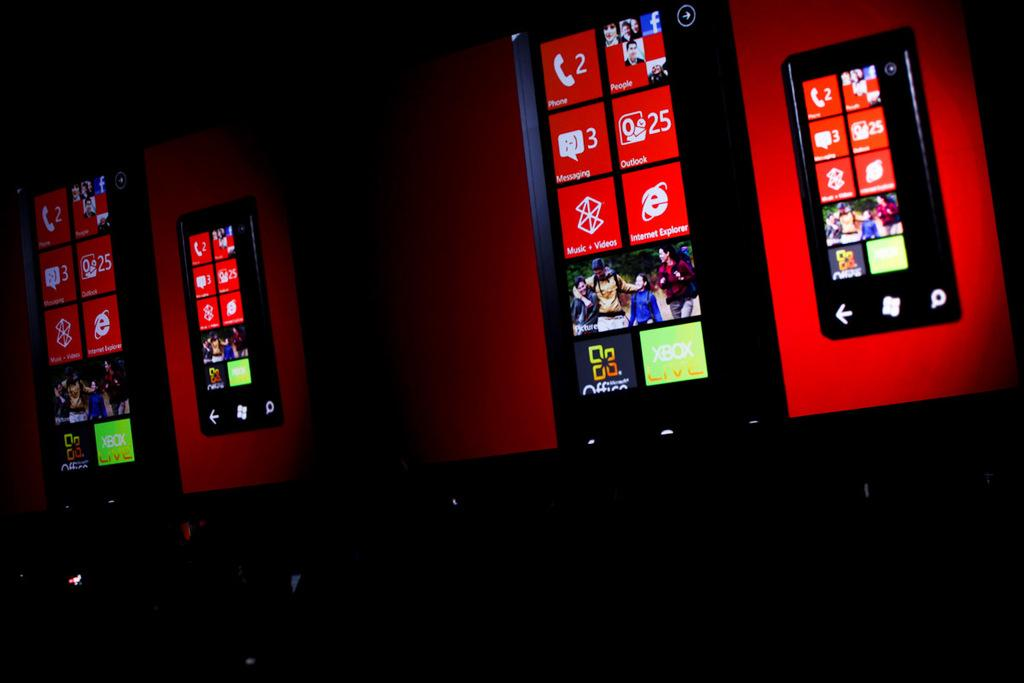<image>
Present a compact description of the photo's key features. Phone screens show tiles including that someone has 3 messages and 25 emails on Outlook. 